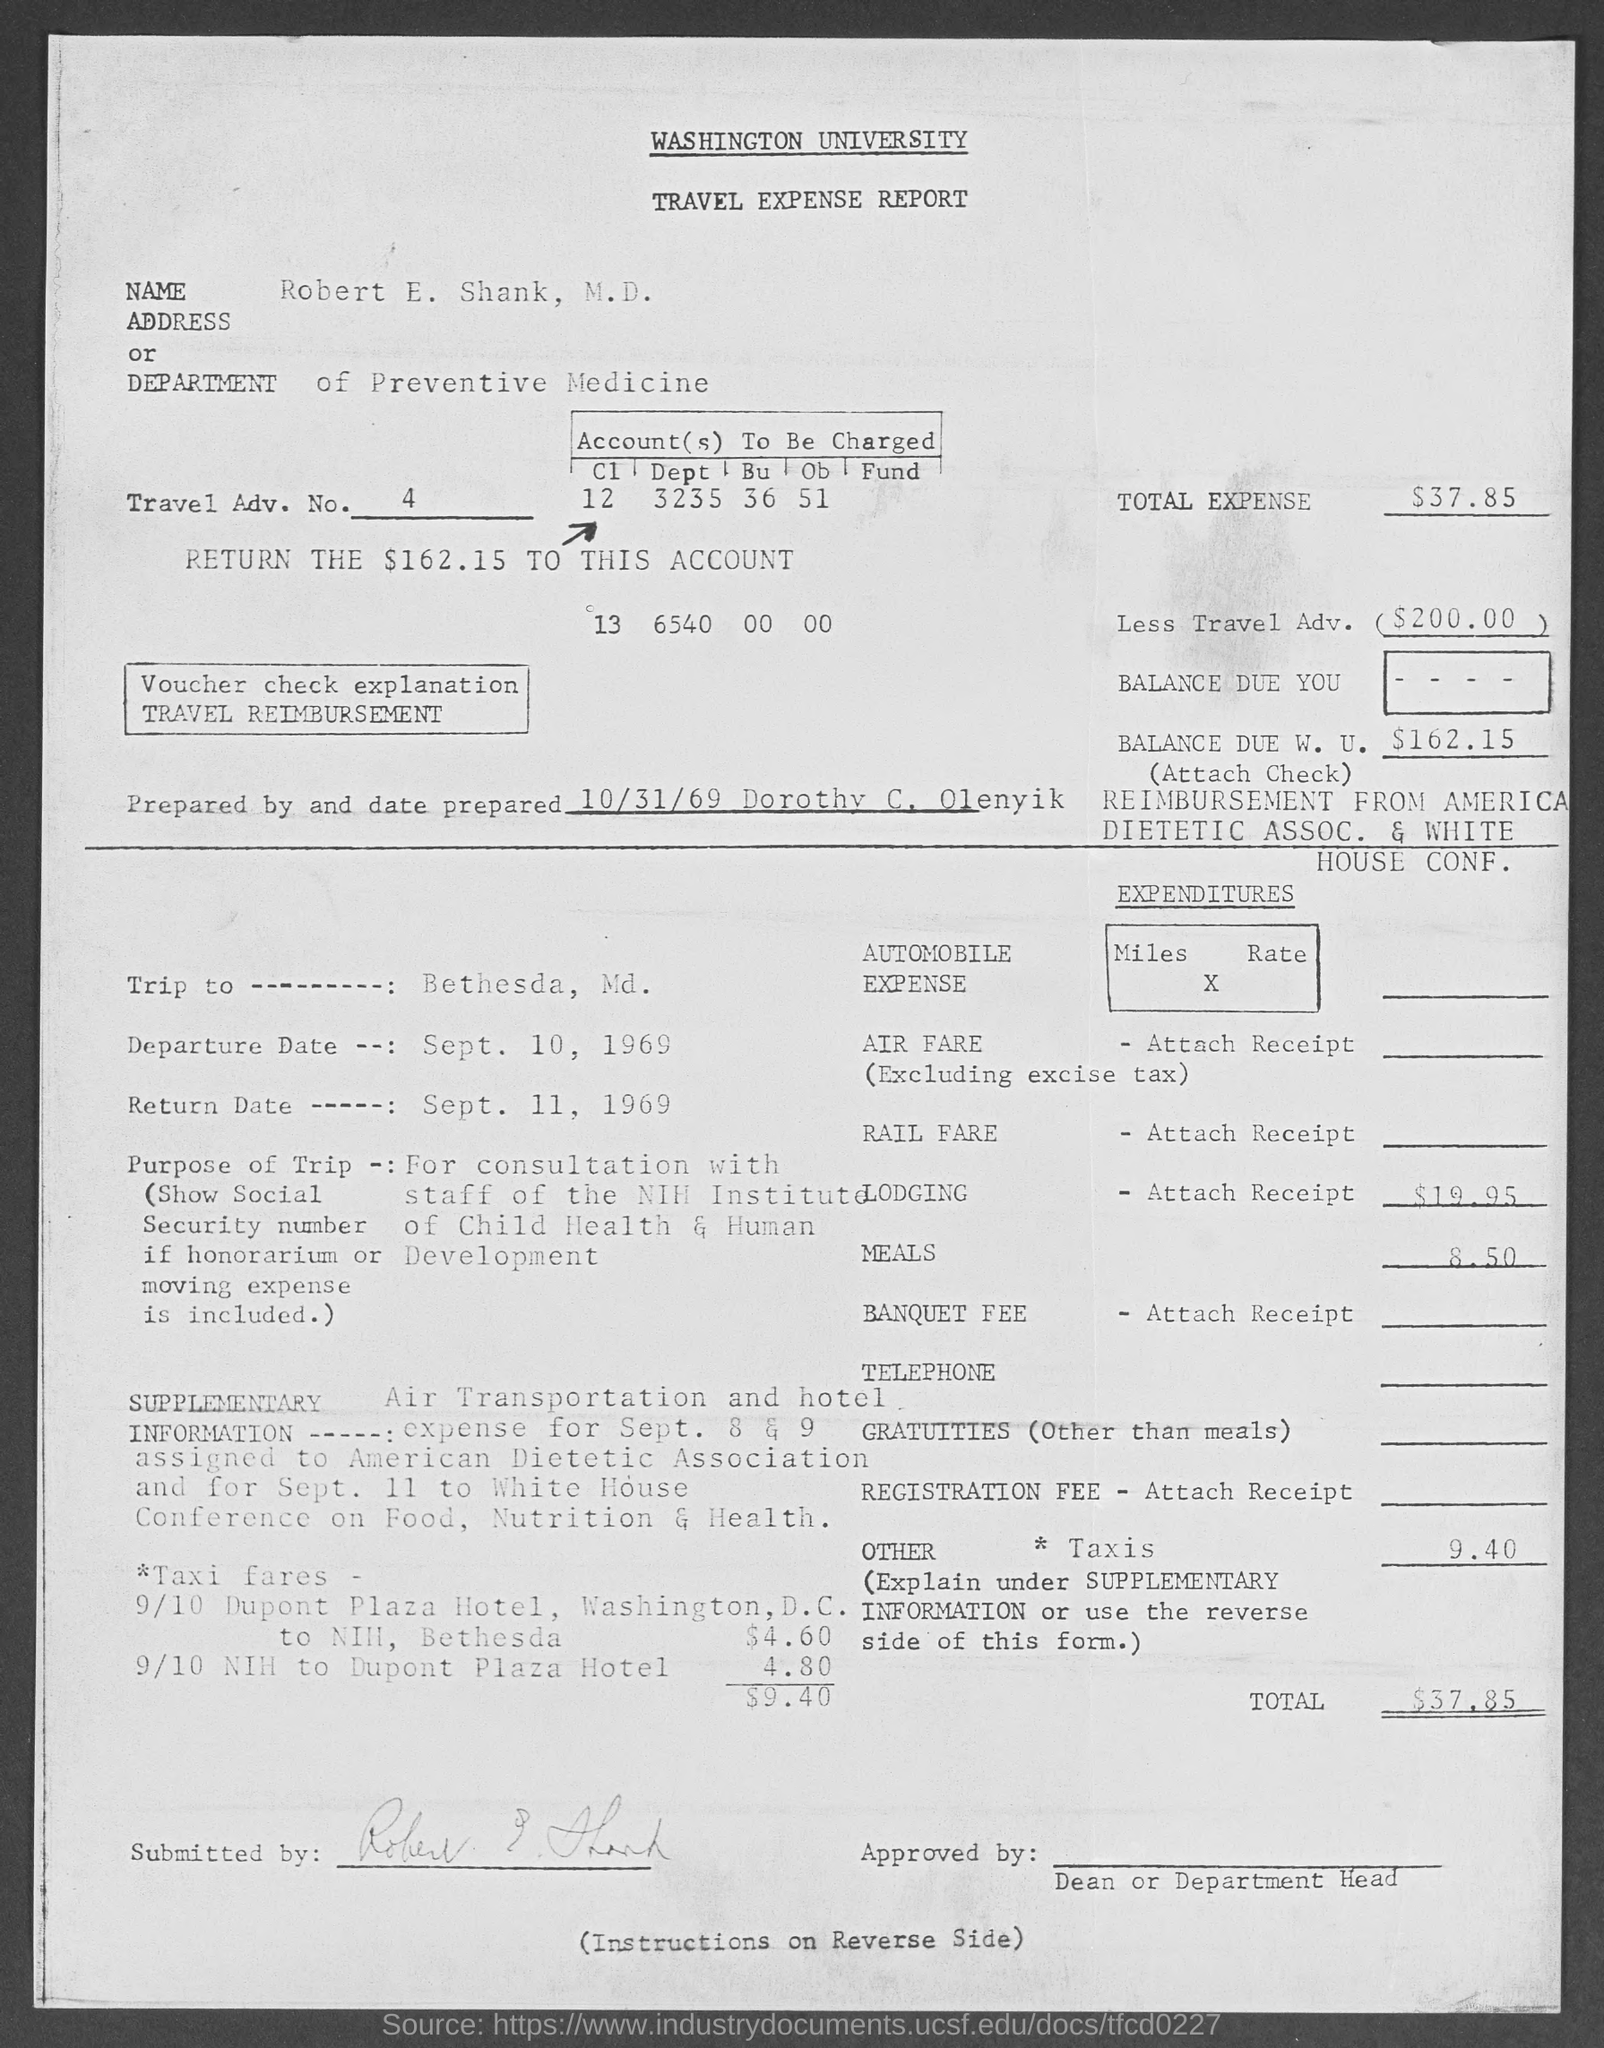Specify some key components in this picture. The travel expense report was prepared by Dorothy C. Olenyik. The departure date mentioned in the travel expense report is September 10, 1969. The travel expense report was prepared on October 31st, 1969. The total expense mentioned in the travel expense report is $37.85. Robert E. Shank, M.D. works in the Department of Preventive Medicine. 